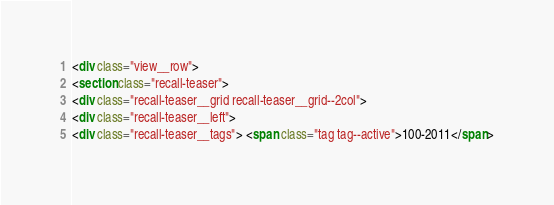<code> <loc_0><loc_0><loc_500><loc_500><_HTML_><div class="view__row">
<section class="recall-teaser">
<div class="recall-teaser__grid recall-teaser__grid--2col">
<div class="recall-teaser__left">
<div class="recall-teaser__tags"> <span class="tag tag--active">100-2011</span></code> 